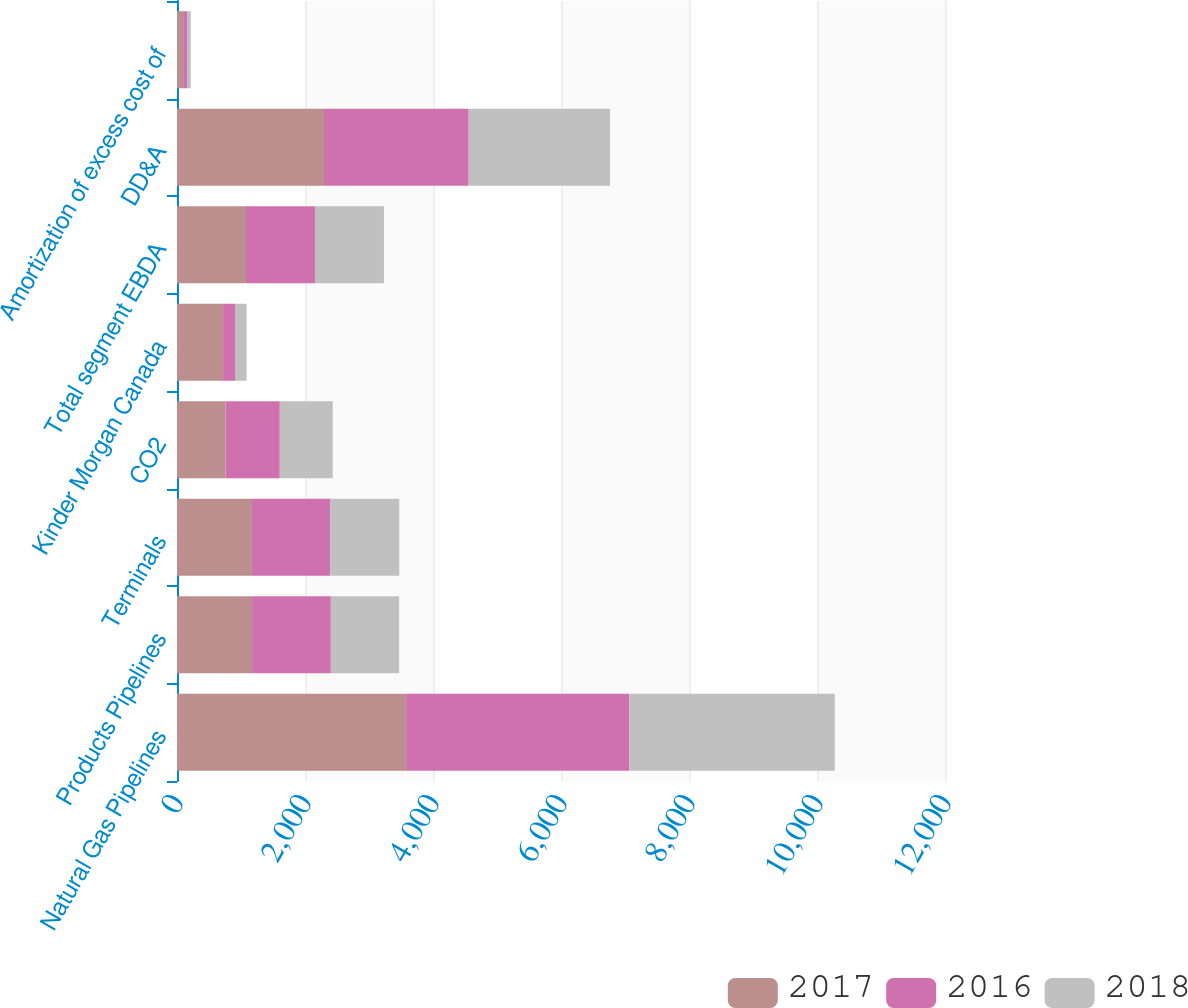<chart> <loc_0><loc_0><loc_500><loc_500><stacked_bar_chart><ecel><fcel>Natural Gas Pipelines<fcel>Products Pipelines<fcel>Terminals<fcel>CO2<fcel>Kinder Morgan Canada<fcel>Total segment EBDA<fcel>DD&A<fcel>Amortization of excess cost of<nl><fcel>2017<fcel>3580<fcel>1173<fcel>1171<fcel>759<fcel>720<fcel>1078<fcel>2297<fcel>95<nl><fcel>2016<fcel>3487<fcel>1231<fcel>1224<fcel>847<fcel>186<fcel>1078<fcel>2261<fcel>61<nl><fcel>2018<fcel>3211<fcel>1067<fcel>1078<fcel>827<fcel>181<fcel>1078<fcel>2209<fcel>59<nl></chart> 